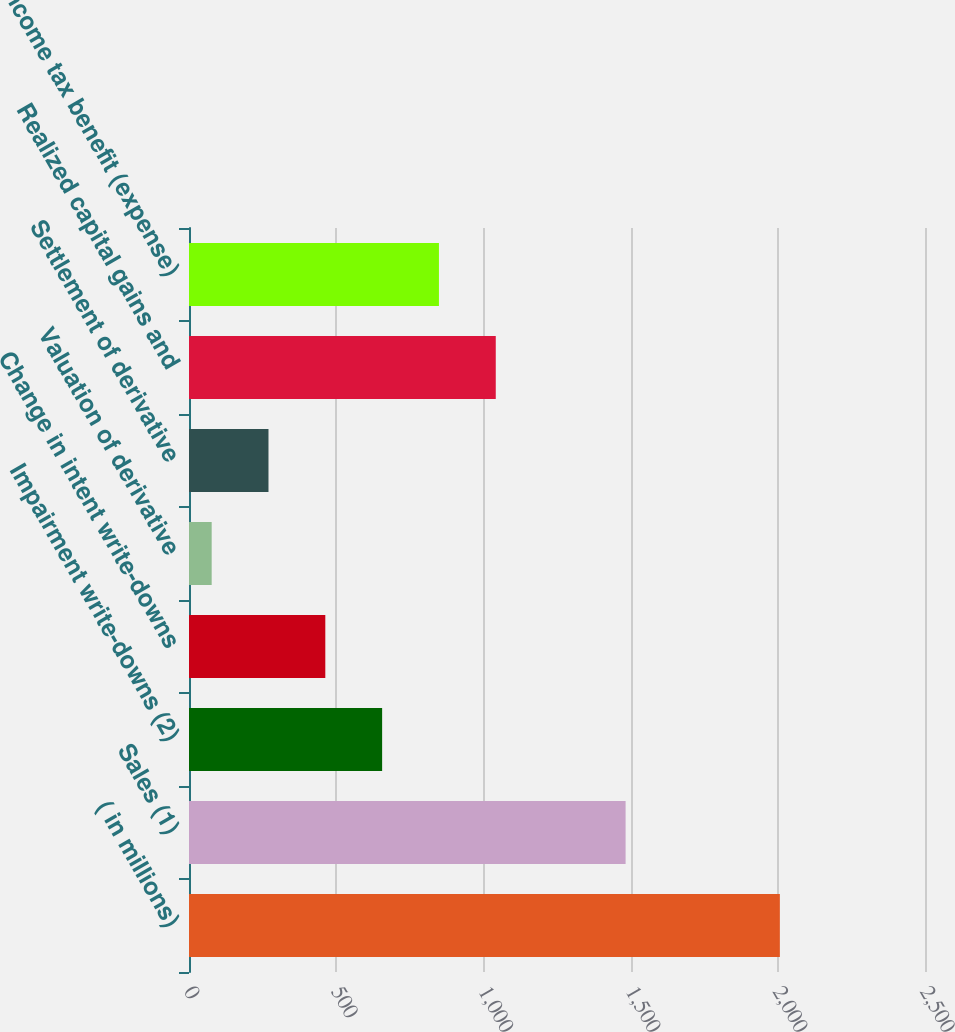<chart> <loc_0><loc_0><loc_500><loc_500><bar_chart><fcel>( in millions)<fcel>Sales (1)<fcel>Impairment write-downs (2)<fcel>Change in intent write-downs<fcel>Valuation of derivative<fcel>Settlement of derivative<fcel>Realized capital gains and<fcel>Income tax benefit (expense)<nl><fcel>2007<fcel>1483<fcel>656<fcel>463<fcel>77<fcel>270<fcel>1042<fcel>849<nl></chart> 